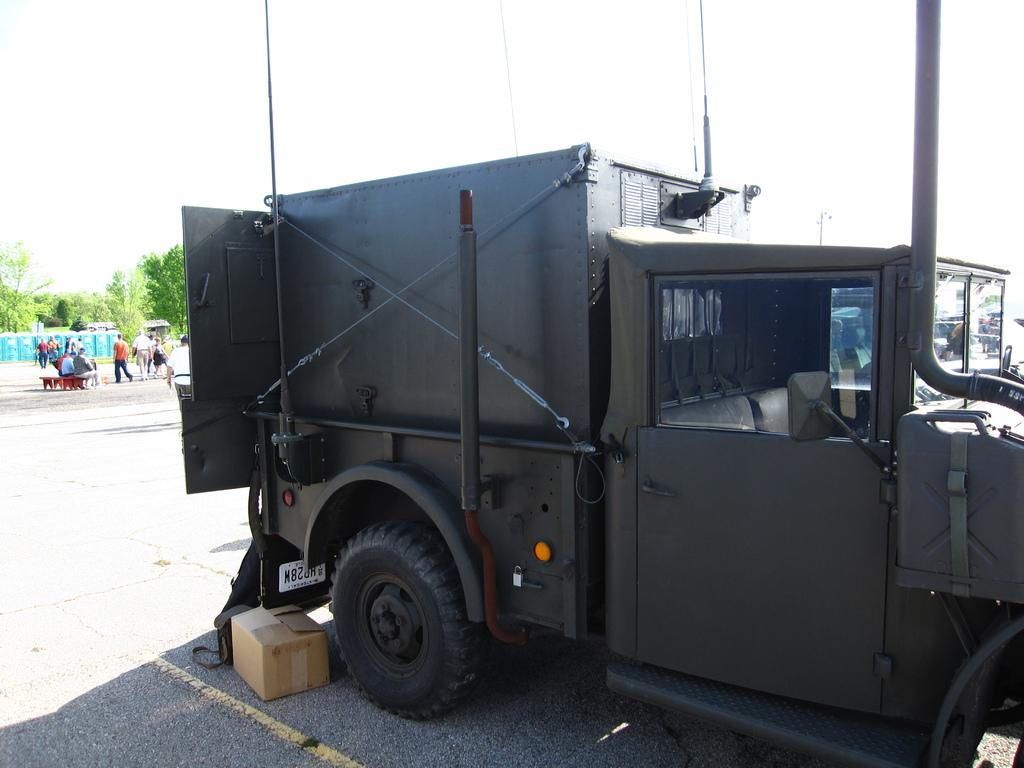What is on the road in the image? There is a vehicle and a box on the road. What are the people in the image doing? There are people sitting on a bench and people walking. What can be seen in the background of the image? There are trees and the sky visible. Is there a metal cobweb hanging from the trees in the image? No, there is no cobweb, metal or otherwise, hanging from the trees in the image. Can you see the brain of one of the people walking in the image? No, the image does not show the brains of the people walking; it only shows their external appearance. 